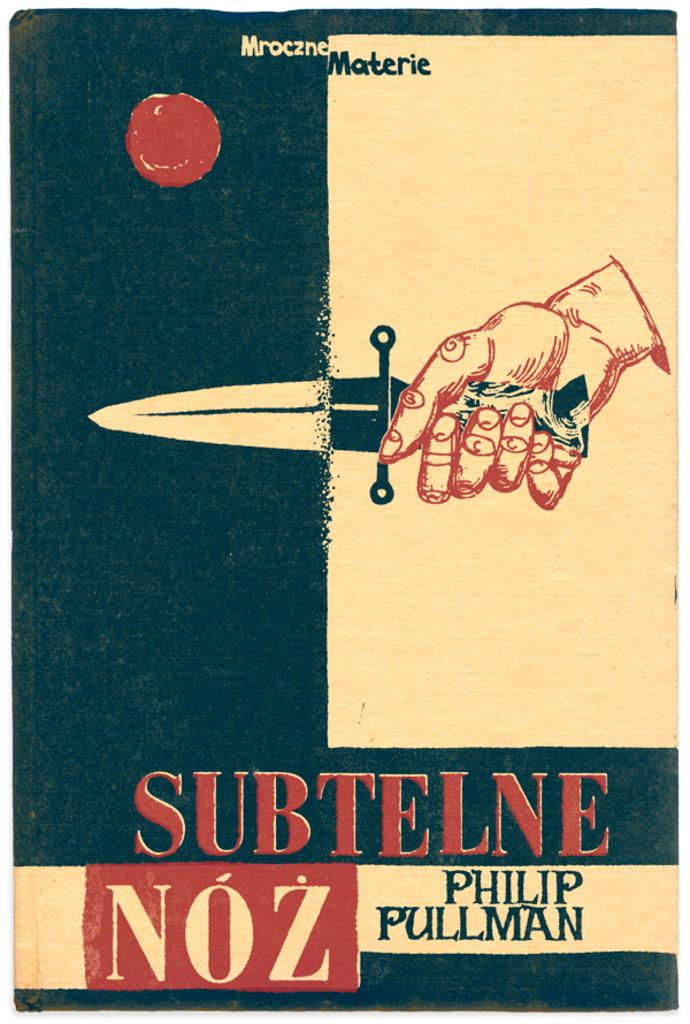<image>
Render a clear and concise summary of the photo. A book by Philip Pullman which shows a man holding a knife on its cover. 